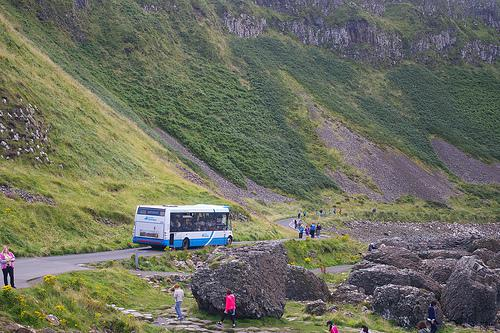Question: what type of landscape is this?
Choices:
A. City.
B. Valley.
C. Mountainside.
D. Plane.
Answer with the letter. Answer: C Question: what vehicle is in the picture?
Choices:
A. A car.
B. A truck.
C. A motorcycle.
D. A bus.
Answer with the letter. Answer: D Question: what shape is the bus?
Choices:
A. Square.
B. Round.
C. Oval.
D. Rectangle.
Answer with the letter. Answer: D Question: what color is the bus?
Choices:
A. Red.
B. Yellow.
C. Black.
D. Blue and white.
Answer with the letter. Answer: D 